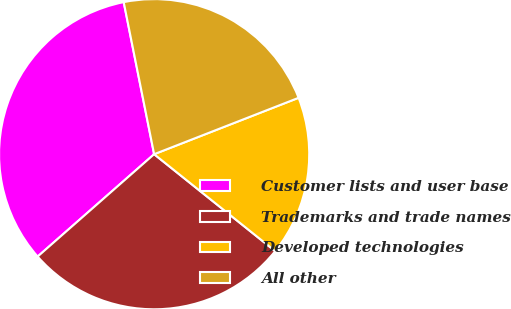Convert chart. <chart><loc_0><loc_0><loc_500><loc_500><pie_chart><fcel>Customer lists and user base<fcel>Trademarks and trade names<fcel>Developed technologies<fcel>All other<nl><fcel>33.33%<fcel>27.78%<fcel>16.67%<fcel>22.22%<nl></chart> 